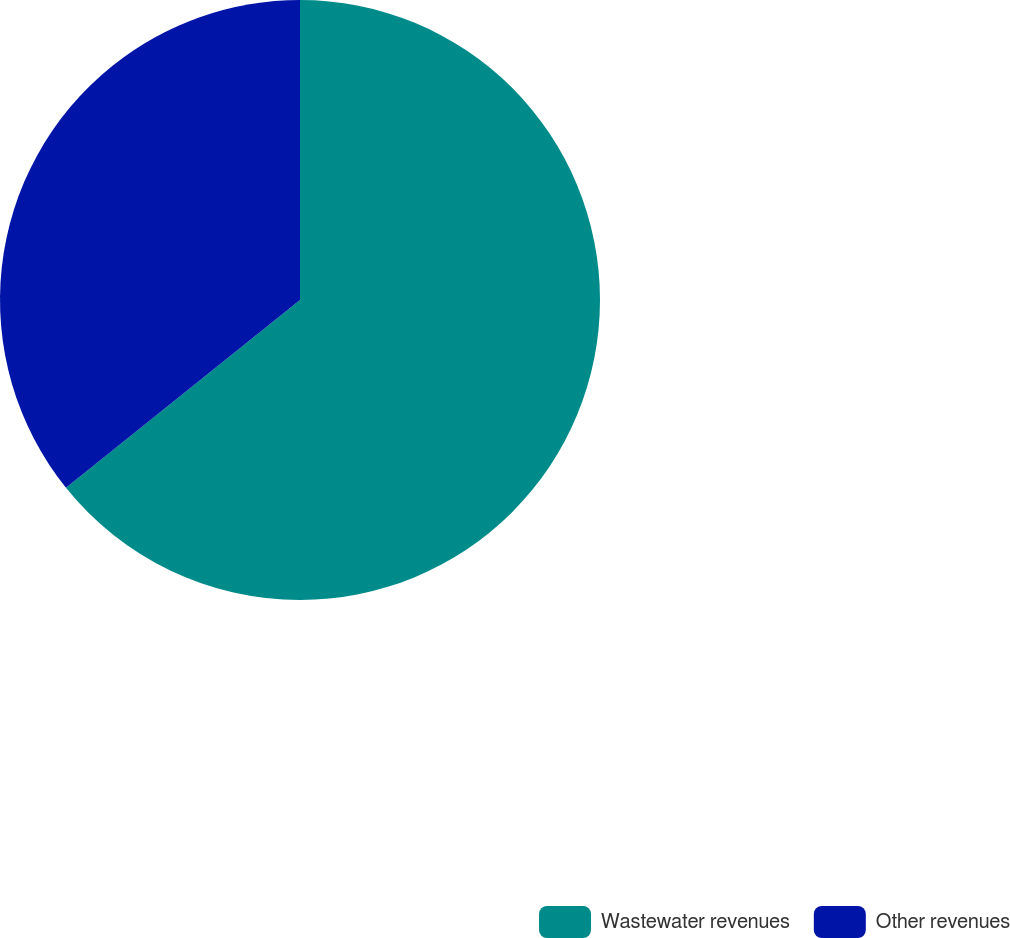<chart> <loc_0><loc_0><loc_500><loc_500><pie_chart><fcel>Wastewater revenues<fcel>Other revenues<nl><fcel>64.24%<fcel>35.76%<nl></chart> 